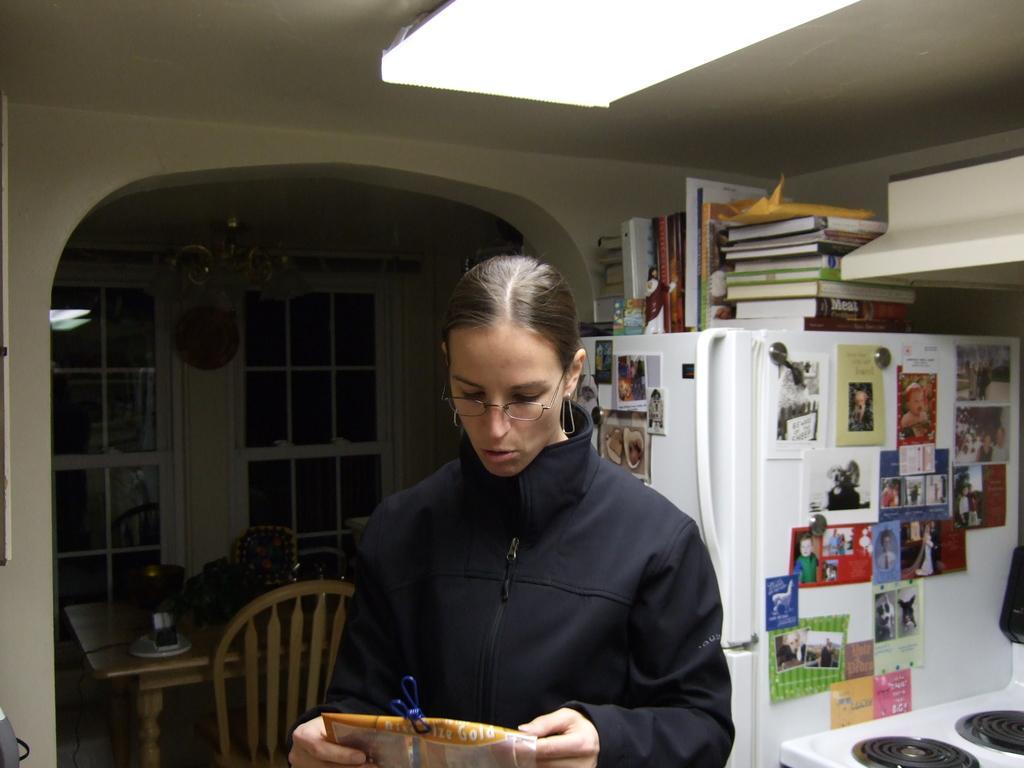Could you give a brief overview of what you see in this image? In this image I can see one person. To the right some boards are attached to the refrigerator. On the refrigerator there are many books. To the left there is a dining table and the window. 